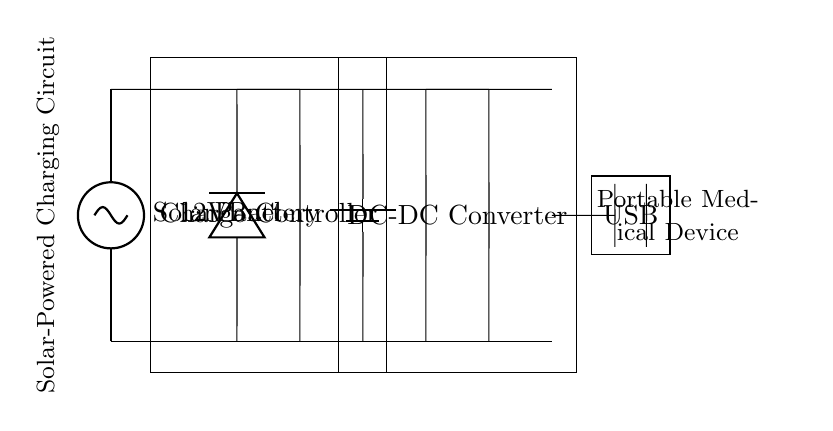What is the source of power in this circuit? The circuit uses a solar panel as its source of power, as indicated by the label on the left side of the diagram.
Answer: Solar Panel What is the purpose of the charge controller? The charge controller regulates the voltage and current from the solar panel to the battery, preventing overcharging or discharging, which is critical for battery safety and longevity.
Answer: Charge Controller What is the voltage rating of the battery? The battery is marked with a voltage label of 12 volts, signifying the potential difference it provides for the circuit.
Answer: 12V What component converts the battery output to a usable voltage? The DC-DC converter in the circuit adjusts the voltage from the battery to the desired level suitable for powering devices, ensuring compatibility with the output requirements.
Answer: DC-DC Converter What is the output type for charging devices? The circuit includes a USB output, which is intended for charging portable medical devices, as commonly used and standard in low power applications.
Answer: USB How does the current flow from the solar panel to the output? The current flows from the solar panel to the charge controller, then to the battery, through the DC-DC converter, and finally reaches the USB output, thus supplying power to the connected device.
Answer: Solar Panel to Charge Controller to Battery to DC-DC Converter to USB What is the role of the diode in the circuit? The diode allows current to flow in only one direction, protecting the circuit components from reverse polarity and ensuring that power only goes from the solar panel to the charge controller.
Answer: Protect against reverse polarity 